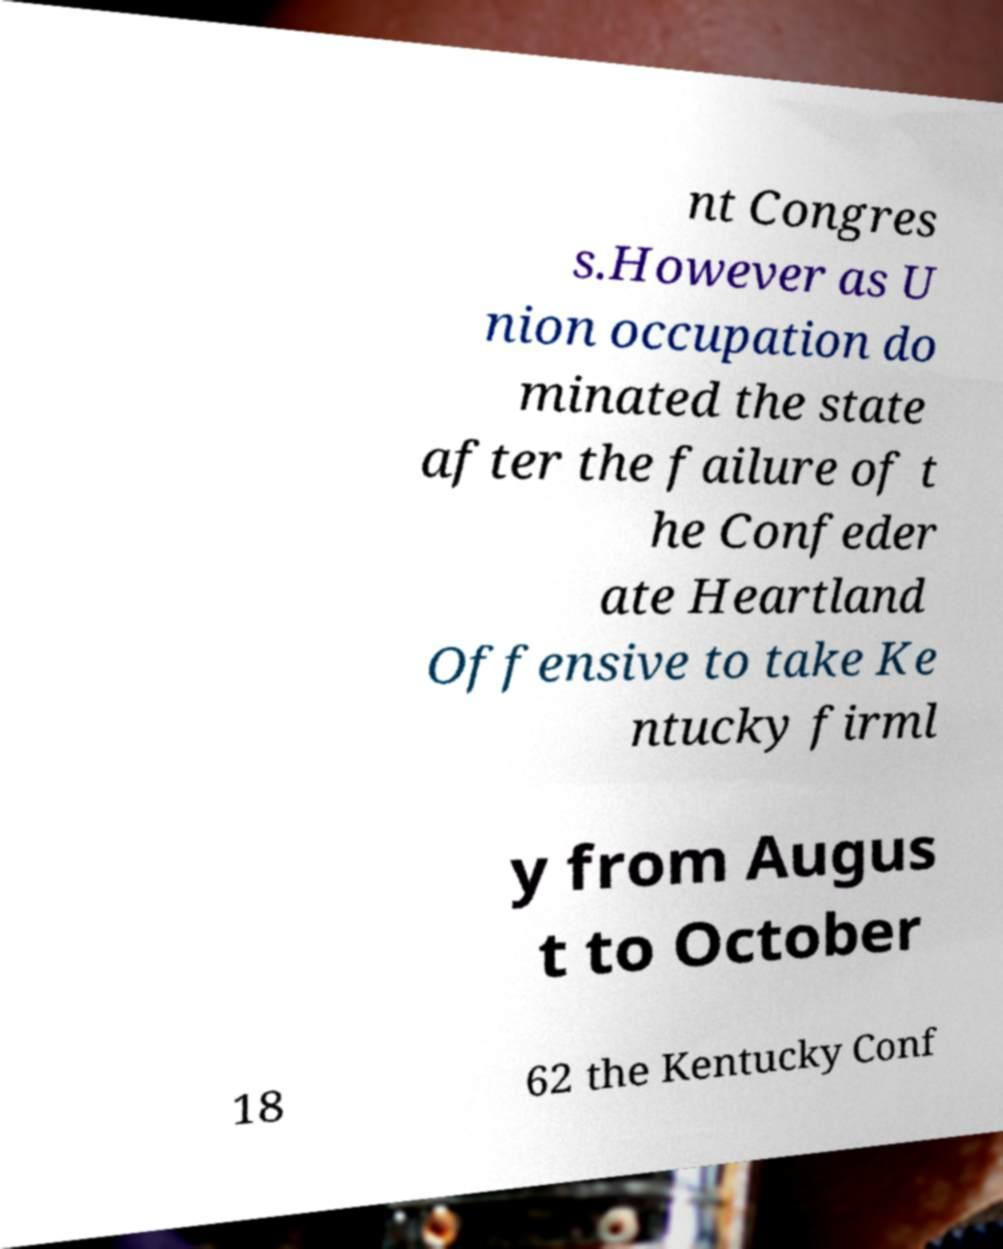For documentation purposes, I need the text within this image transcribed. Could you provide that? nt Congres s.However as U nion occupation do minated the state after the failure of t he Confeder ate Heartland Offensive to take Ke ntucky firml y from Augus t to October 18 62 the Kentucky Conf 